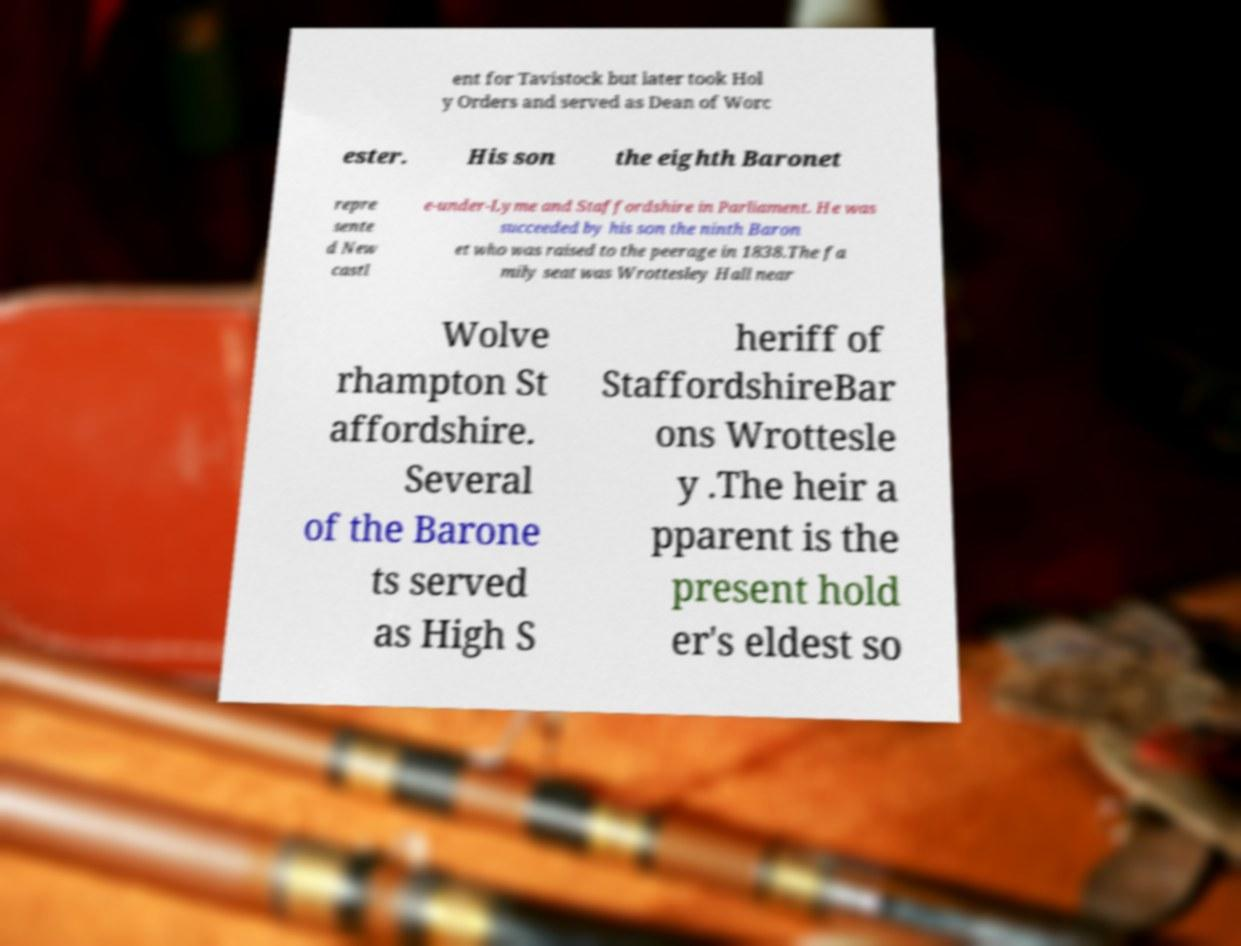I need the written content from this picture converted into text. Can you do that? ent for Tavistock but later took Hol y Orders and served as Dean of Worc ester. His son the eighth Baronet repre sente d New castl e-under-Lyme and Staffordshire in Parliament. He was succeeded by his son the ninth Baron et who was raised to the peerage in 1838.The fa mily seat was Wrottesley Hall near Wolve rhampton St affordshire. Several of the Barone ts served as High S heriff of StaffordshireBar ons Wrottesle y .The heir a pparent is the present hold er's eldest so 